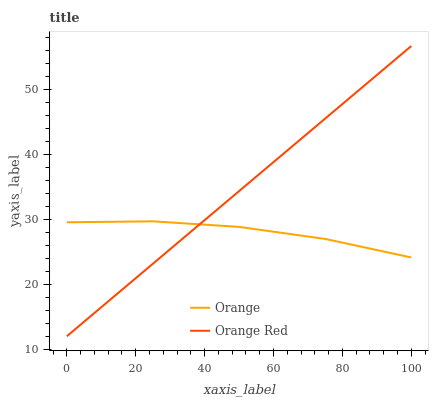Does Orange have the minimum area under the curve?
Answer yes or no. Yes. Does Orange Red have the maximum area under the curve?
Answer yes or no. Yes. Does Orange Red have the minimum area under the curve?
Answer yes or no. No. Is Orange Red the smoothest?
Answer yes or no. Yes. Is Orange the roughest?
Answer yes or no. Yes. Is Orange Red the roughest?
Answer yes or no. No. Does Orange Red have the lowest value?
Answer yes or no. Yes. Does Orange Red have the highest value?
Answer yes or no. Yes. Does Orange Red intersect Orange?
Answer yes or no. Yes. Is Orange Red less than Orange?
Answer yes or no. No. Is Orange Red greater than Orange?
Answer yes or no. No. 